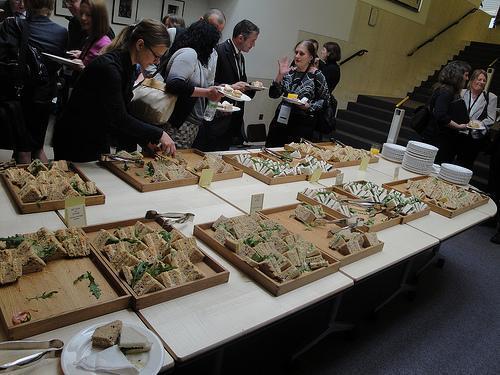How many trays of sandwiches are on the table?
Give a very brief answer. 12. 